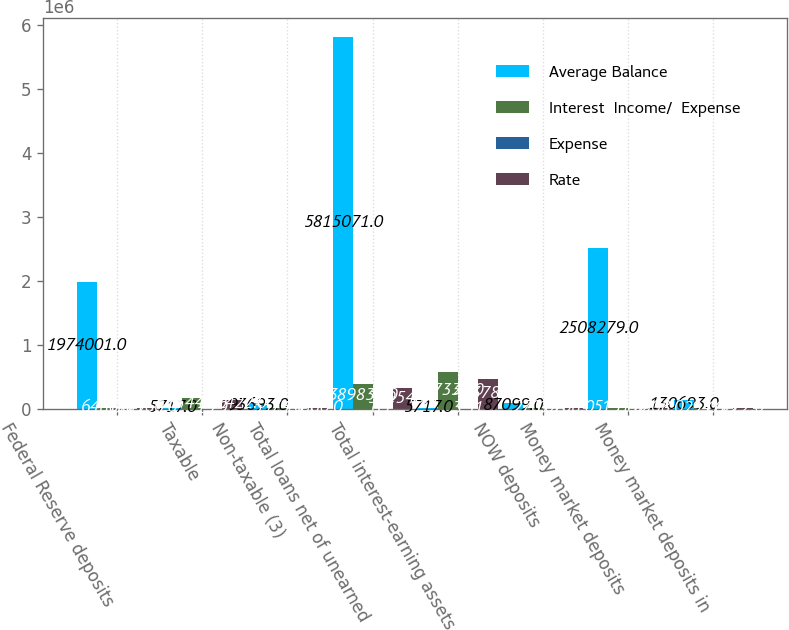<chart> <loc_0><loc_0><loc_500><loc_500><stacked_bar_chart><ecel><fcel>Federal Reserve deposits<fcel>Taxable<fcel>Non-taxable (3)<fcel>Total loans net of unearned<fcel>Total interest-earning assets<fcel>NOW deposits<fcel>Money market deposits<fcel>Money market deposits in<nl><fcel>Average Balance<fcel>1.974e+06<fcel>5717<fcel>93693<fcel>5.81507e+06<fcel>5717<fcel>87099<fcel>2.50828e+06<fcel>130693<nl><fcel>Interest  Income/  Expense<fcel>6486<fcel>165449<fcel>5574<fcel>389830<fcel>567339<fcel>270<fcel>5131<fcel>294<nl><fcel>Expense<fcel>0.33<fcel>1.79<fcel>5.95<fcel>6.7<fcel>3.31<fcel>0.31<fcel>0.2<fcel>0.22<nl><fcel>Rate<fcel>10960<fcel>127422<fcel>5860<fcel>319540<fcel>463782<fcel>208<fcel>5308<fcel>272<nl></chart> 